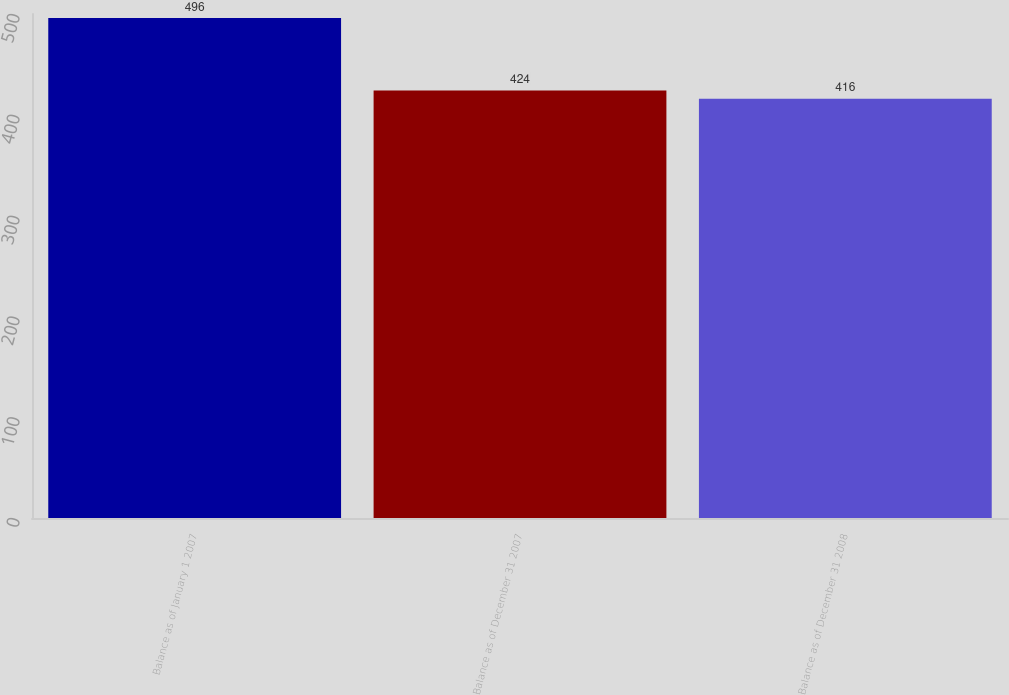Convert chart to OTSL. <chart><loc_0><loc_0><loc_500><loc_500><bar_chart><fcel>Balance as of January 1 2007<fcel>Balance as of December 31 2007<fcel>Balance as of December 31 2008<nl><fcel>496<fcel>424<fcel>416<nl></chart> 